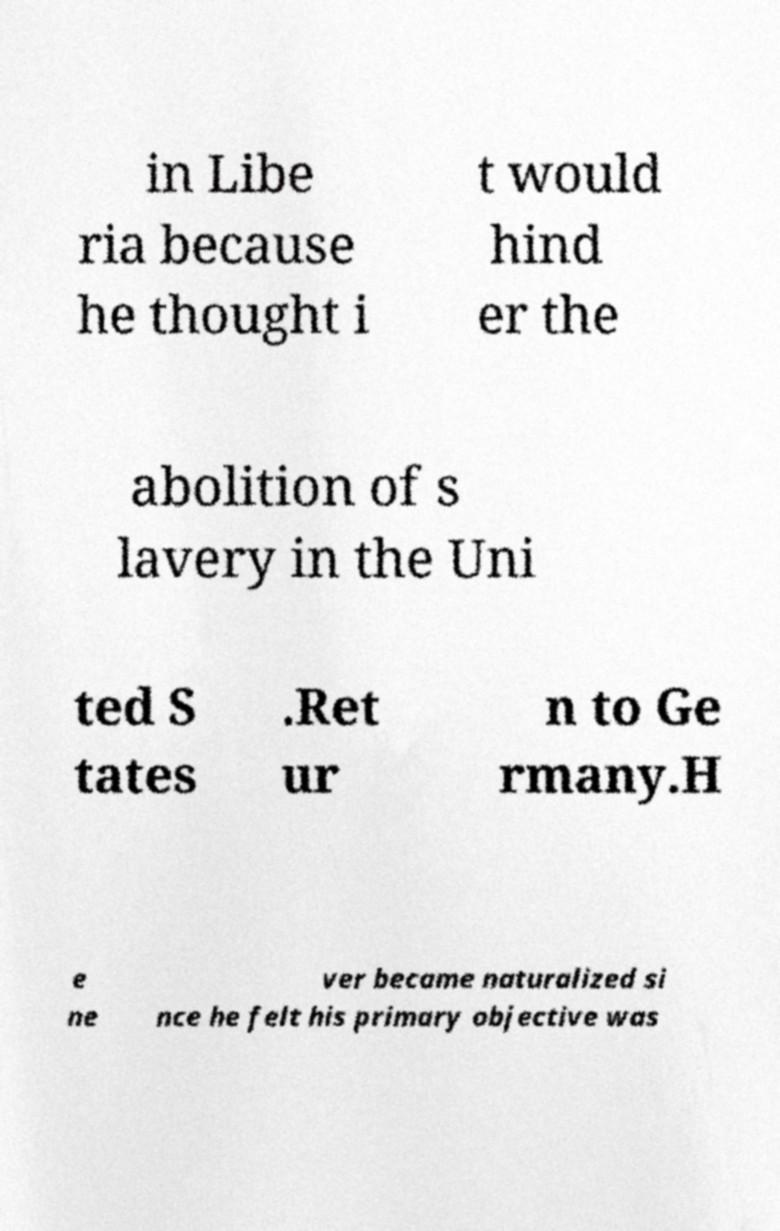Please read and relay the text visible in this image. What does it say? in Libe ria because he thought i t would hind er the abolition of s lavery in the Uni ted S tates .Ret ur n to Ge rmany.H e ne ver became naturalized si nce he felt his primary objective was 